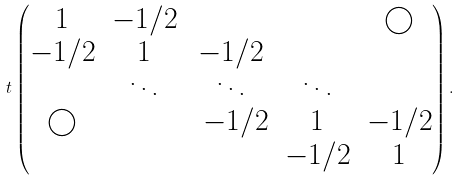<formula> <loc_0><loc_0><loc_500><loc_500>t \begin{pmatrix} 1 & - 1 / 2 & & & \bigcirc \\ - 1 / 2 & 1 & - 1 / 2 \\ & \ddots & \ddots & \ddots \\ \bigcirc & & \ - 1 / 2 & 1 & - 1 / 2 \\ & & & - 1 / 2 & 1 \end{pmatrix} . \\</formula> 